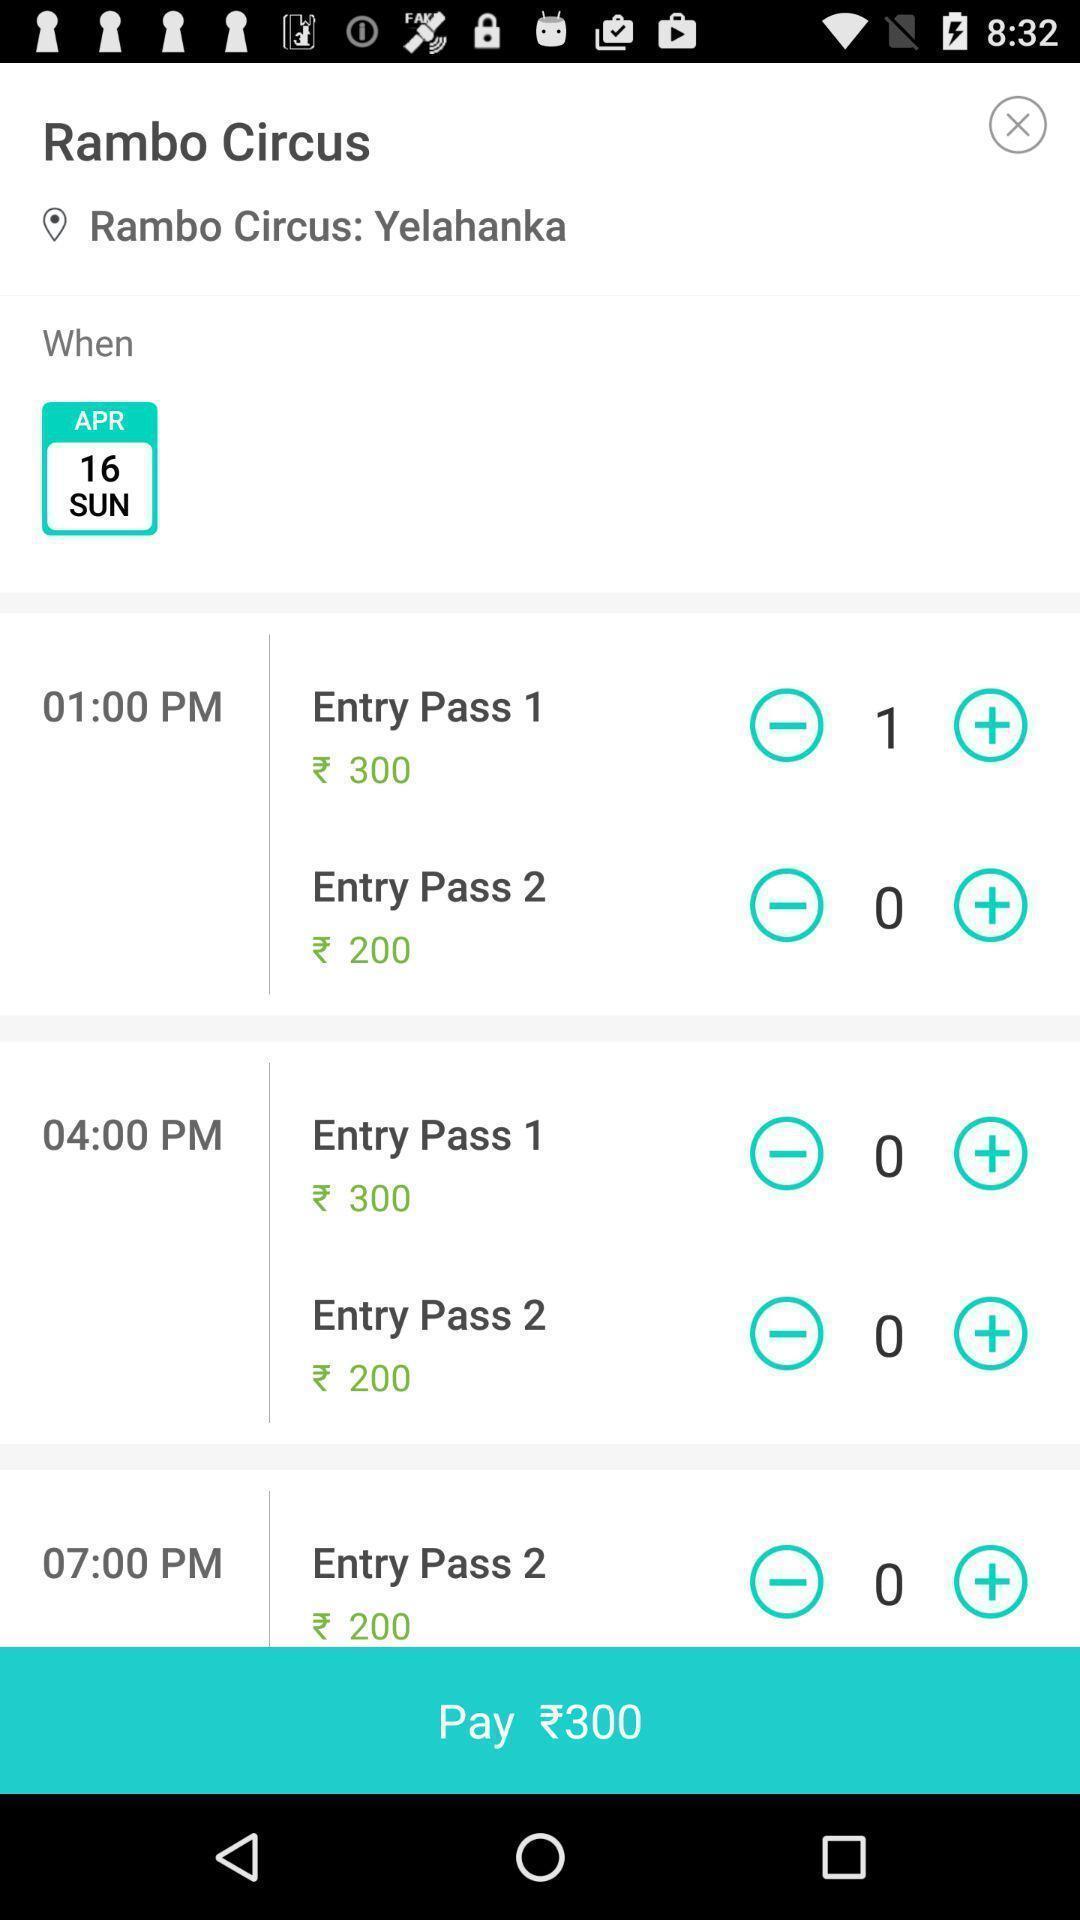Give me a narrative description of this picture. Payment page to book a ticket for circus. 